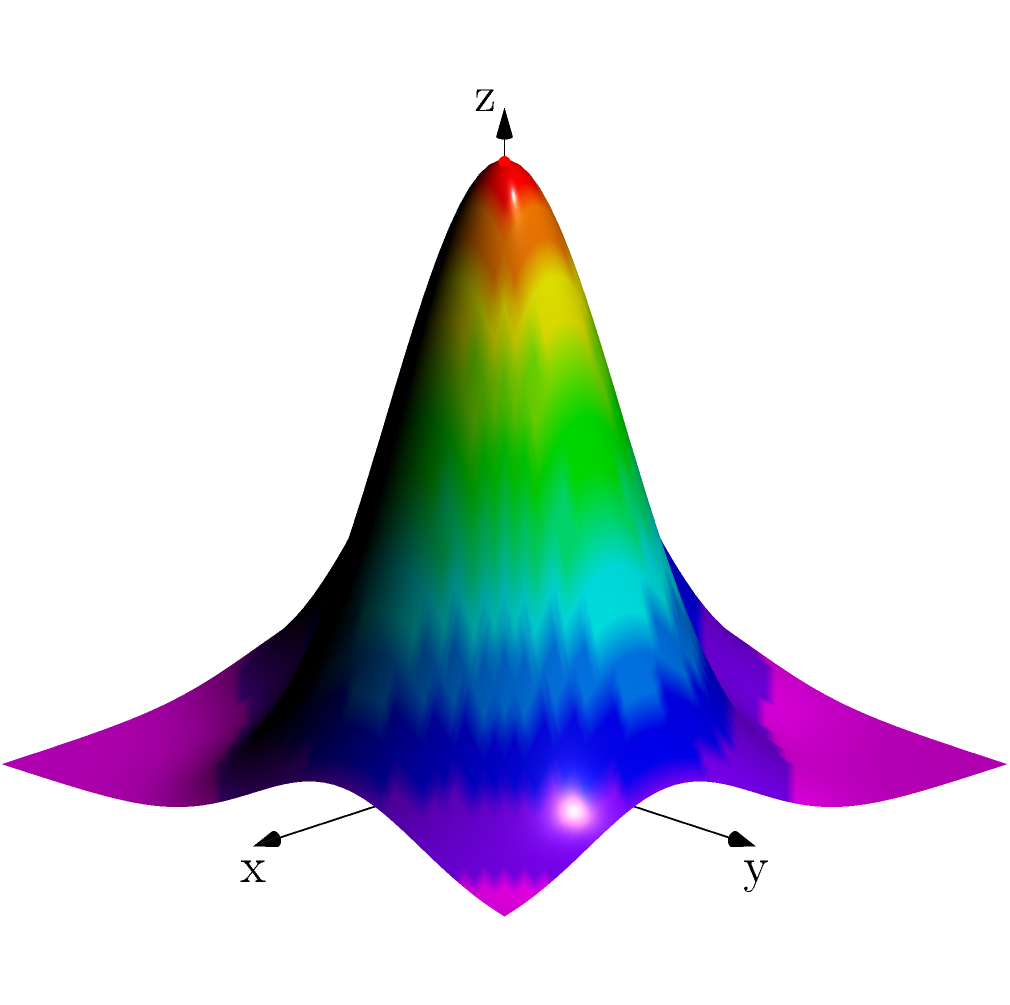Based on the 3D surface model shown, which settlement location (red or blue dot) would likely have been preferred by ancient civilizations, and why? To determine the preferred settlement location, we need to analyze the terrain features represented in the 3D surface model:

1. Elevation: The red dot is located on a higher elevation compared to the blue dot. Higher ground often provides better defensive advantages and protection from flooding.

2. Slope: The area around the red dot has a gentler slope, which is more suitable for building structures and agriculture. The blue dot is in a steeper area, which would make construction and farming more challenging.

3. Water accessibility: The red dot is situated near the edge of a plateau, which might indicate proximity to water sources like rivers or streams flowing in the lower areas. The blue dot is in a depression, which could be prone to water accumulation but might lack fresh water sources.

4. Visibility: The higher elevation of the red dot offers a better vantage point for surveying the surrounding landscape, which is crucial for defense and resource management.

5. Resource availability: The more varied terrain around the red dot suggests a diverse ecosystem, potentially offering a wider range of resources for the settlement.

6. Climate considerations: The higher elevation of the red dot might provide better air circulation and cooler temperatures compared to the lower-lying blue dot area.

Given these factors, ancient civilizations would likely have preferred the location marked by the red dot. It offers better defensive positions, more suitable terrain for construction and agriculture, potential access to water sources, and superior visibility of the surrounding area.
Answer: Red dot location 